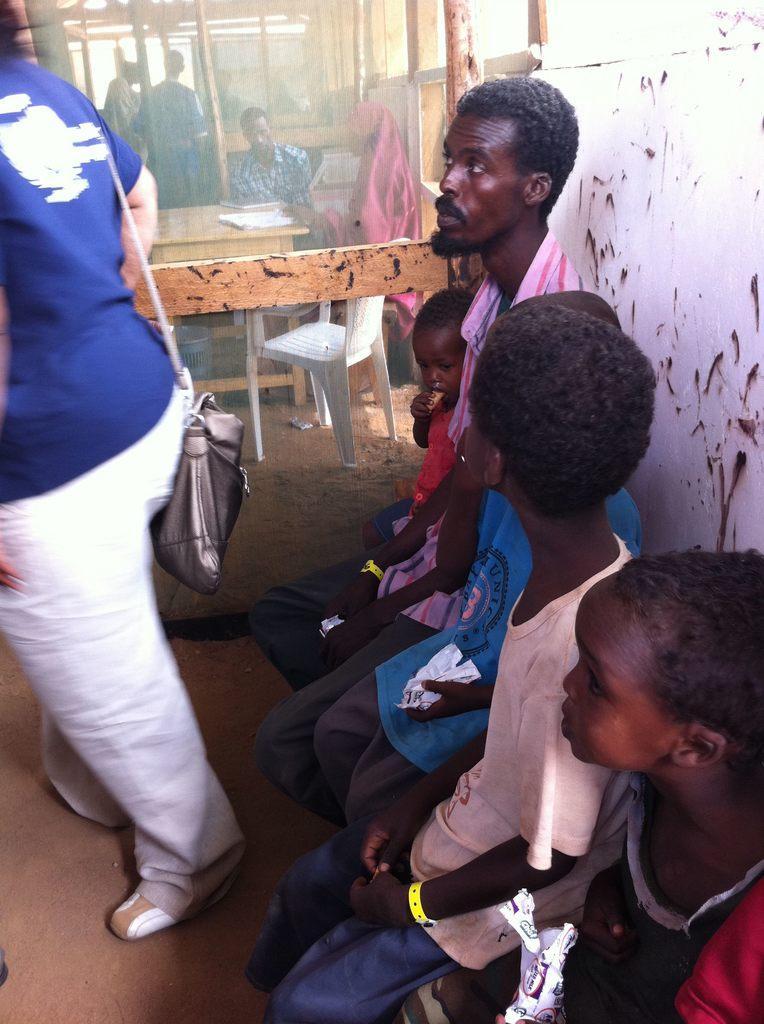Describe this image in one or two sentences. In this image there are persons standing and sitting. There is an empty chair and there is a table and on the table there are papers. 